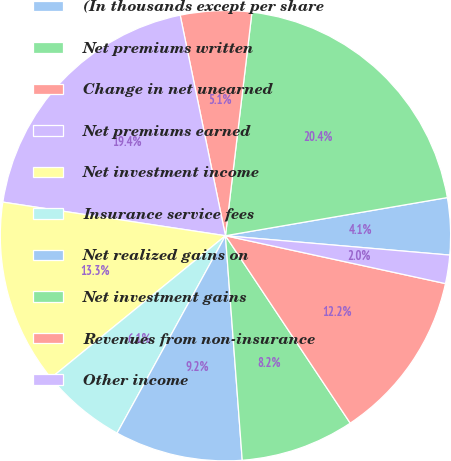Convert chart. <chart><loc_0><loc_0><loc_500><loc_500><pie_chart><fcel>(In thousands except per share<fcel>Net premiums written<fcel>Change in net unearned<fcel>Net premiums earned<fcel>Net investment income<fcel>Insurance service fees<fcel>Net realized gains on<fcel>Net investment gains<fcel>Revenues from non-insurance<fcel>Other income<nl><fcel>4.08%<fcel>20.41%<fcel>5.1%<fcel>19.39%<fcel>13.27%<fcel>6.12%<fcel>9.18%<fcel>8.16%<fcel>12.24%<fcel>2.04%<nl></chart> 